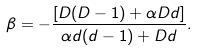<formula> <loc_0><loc_0><loc_500><loc_500>\beta = - \frac { [ D ( D - 1 ) + \alpha D d ] } { \alpha d ( d - 1 ) + D d } .</formula> 